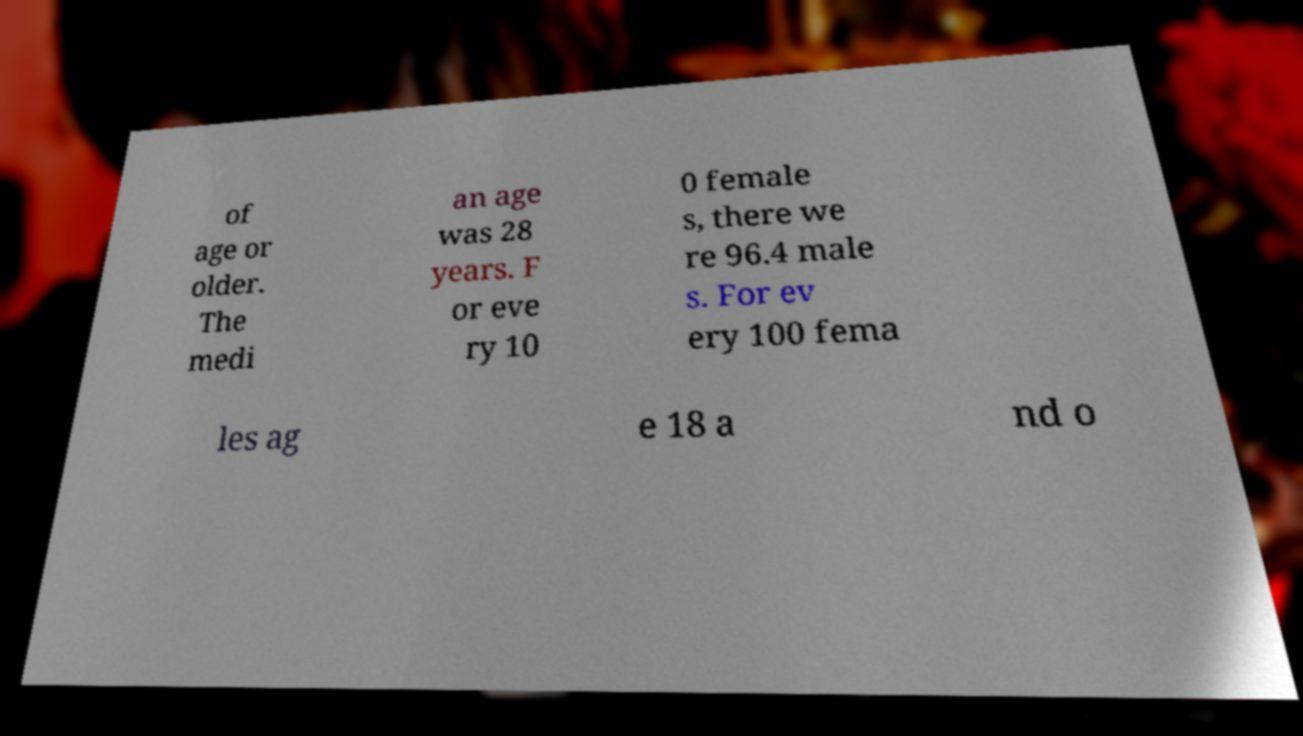I need the written content from this picture converted into text. Can you do that? of age or older. The medi an age was 28 years. F or eve ry 10 0 female s, there we re 96.4 male s. For ev ery 100 fema les ag e 18 a nd o 